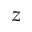Convert formula to latex. <formula><loc_0><loc_0><loc_500><loc_500>z</formula> 